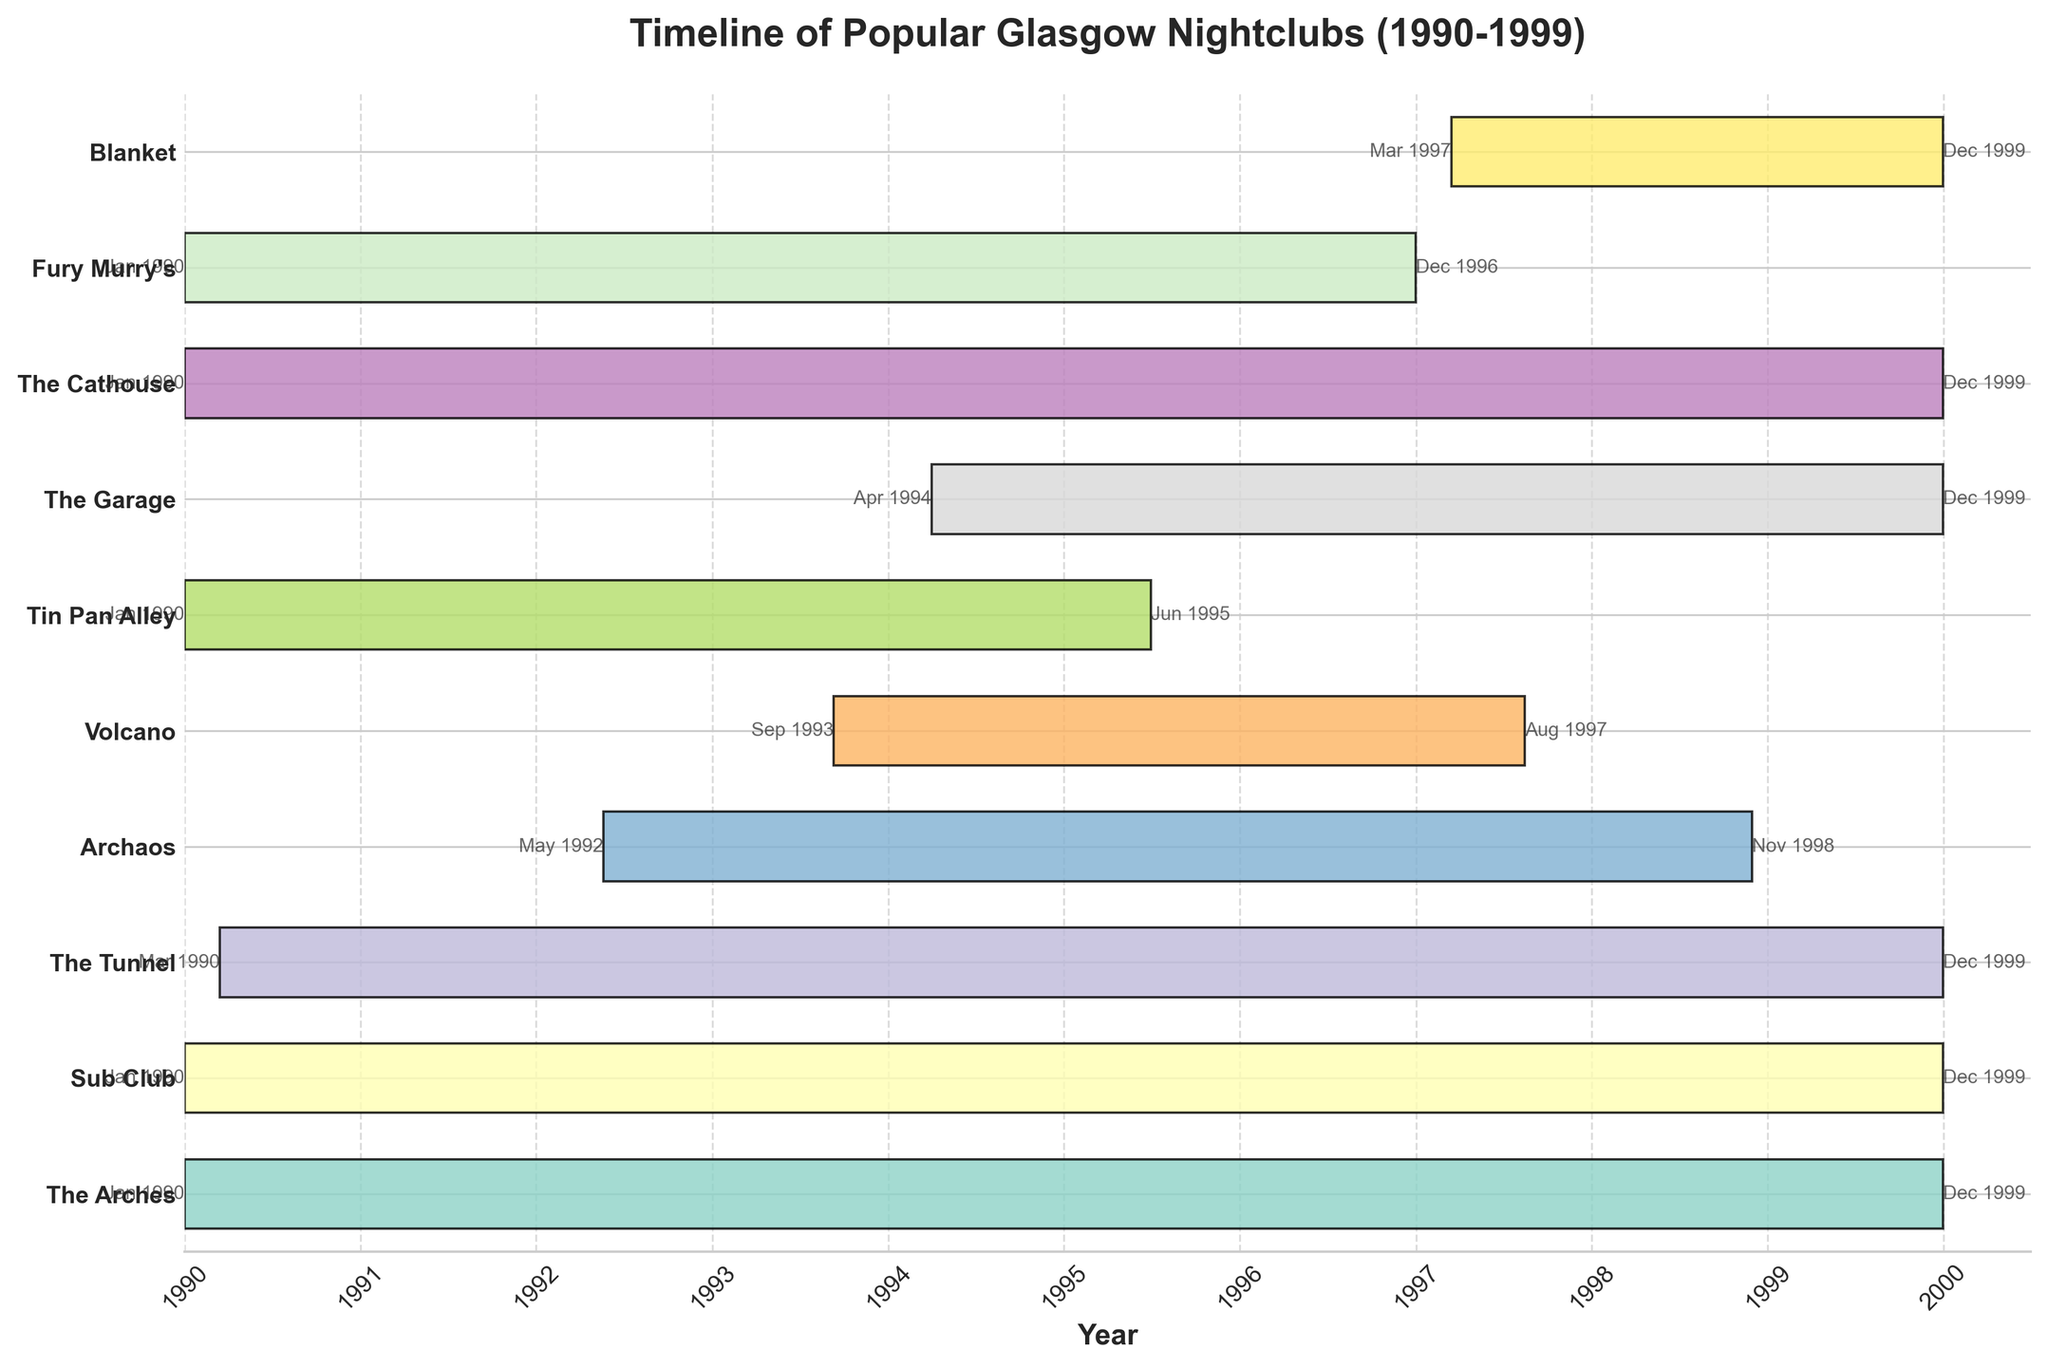What is the total duration for which "The Arches" was operational? "The Arches" opened in January 1990 and closed in December 1999. The total duration is 9 years and 12 months.
Answer: 10 years How many nightclubs were operational throughout the entire period from 1990 to 1999? By examining the end dates, four nightclubs (The Arches, Sub Club, The Tunnel, The Garage, The Cathouse) operated from 1990 to 1999 without gaps.
Answer: 5 Which nightclub had the shortest operational period? "Volcano" was operational from September 1993 to August 1997, making it the shortest duration in the figure.
Answer: Volcano How many nightclubs opened in 1990? Nightclubs "The Arches," "Sub Club," "The Tunnel," "Tin Pan Alley," "The Cathouse," and "Fury Murry's" all opened in 1990, as indicated by their start dates.
Answer: 6 Which nightclub closed first? "Tin Pan Alley" closed in June 1995, which is earlier than the closing years of other nightclubs.
Answer: Tin Pan Alley What year did "The Garage" open? "The Garage" opened in April 1994, as shown by its starting point on the timeline.
Answer: 1994 Which nightclub had the second shortest operational period? "Archaos" was operational from May 1992 to November 1998. This makes it the second shortest after "Volcano" and shorter than other nightclubs like "Blanket."
Answer: Archaos Did "Fury Murry’s" operate longer than "Volcano"? "Fury Murry's" operated from January 1990 to December 1996, which is nearly 7 years, longer than "Volcano" which operated for almost 4 years from September 1993 to August 1997.
Answer: Yes How many nightclubs that opened after 1990 were still operational at the end of 1999? "The Garage" (opened 1994) and "Blanket" (opened 1997) were still operational by the end of 1999.
Answer: 2 